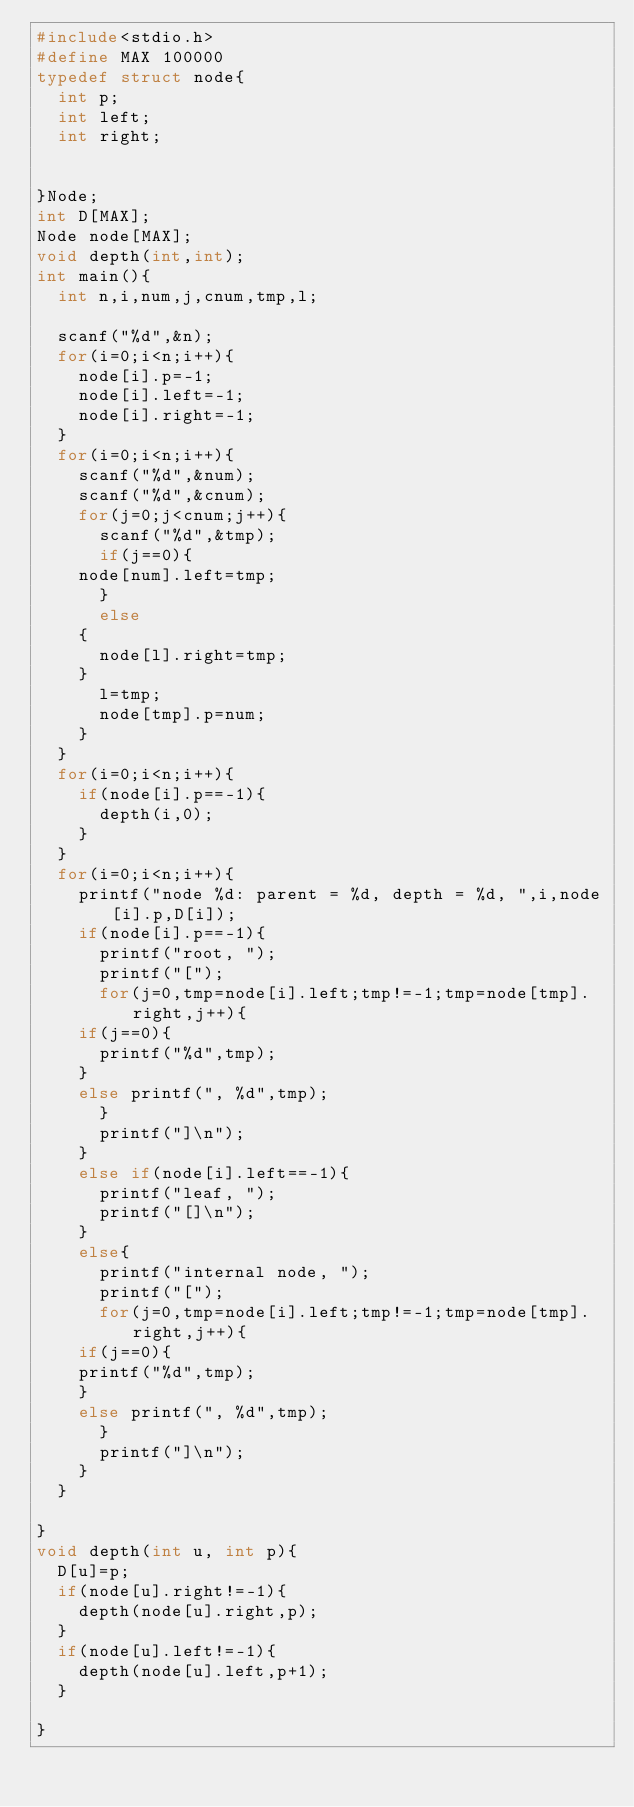<code> <loc_0><loc_0><loc_500><loc_500><_C_>#include<stdio.h>
#define MAX 100000
typedef struct node{
  int p;
  int left;
  int right;
 

}Node;
int D[MAX];
Node node[MAX];
void depth(int,int);
int main(){
  int n,i,num,j,cnum,tmp,l;
 
  scanf("%d",&n);
  for(i=0;i<n;i++){
    node[i].p=-1;
    node[i].left=-1;
    node[i].right=-1;
  }
  for(i=0;i<n;i++){
    scanf("%d",&num);
    scanf("%d",&cnum);
    for(j=0;j<cnum;j++){
      scanf("%d",&tmp);
      if(j==0){
	node[num].left=tmp;
      }
      else
	{
	  node[l].right=tmp;
	}
      l=tmp;
      node[tmp].p=num;
    }   
  }
  for(i=0;i<n;i++){
    if(node[i].p==-1){
      depth(i,0);
    }
  }
  for(i=0;i<n;i++){
    printf("node %d: parent = %d, depth = %d, ",i,node[i].p,D[i]);
    if(node[i].p==-1){
      printf("root, ");
      printf("[");
      for(j=0,tmp=node[i].left;tmp!=-1;tmp=node[tmp].right,j++){
	if(j==0){
	  printf("%d",tmp);
	}
	else printf(", %d",tmp);
      }
      printf("]\n");
    }
    else if(node[i].left==-1){
      printf("leaf, ");
      printf("[]\n");
    }
    else{
      printf("internal node, ");
      printf("[");
      for(j=0,tmp=node[i].left;tmp!=-1;tmp=node[tmp].right,j++){
	if(j==0){
	printf("%d",tmp);
	}
	else printf(", %d",tmp);
      }
      printf("]\n");
    }
  }
 
}
void depth(int u, int p){
  D[u]=p;
  if(node[u].right!=-1){
    depth(node[u].right,p);
  }
  if(node[u].left!=-1){
    depth(node[u].left,p+1);
  }

}

</code> 